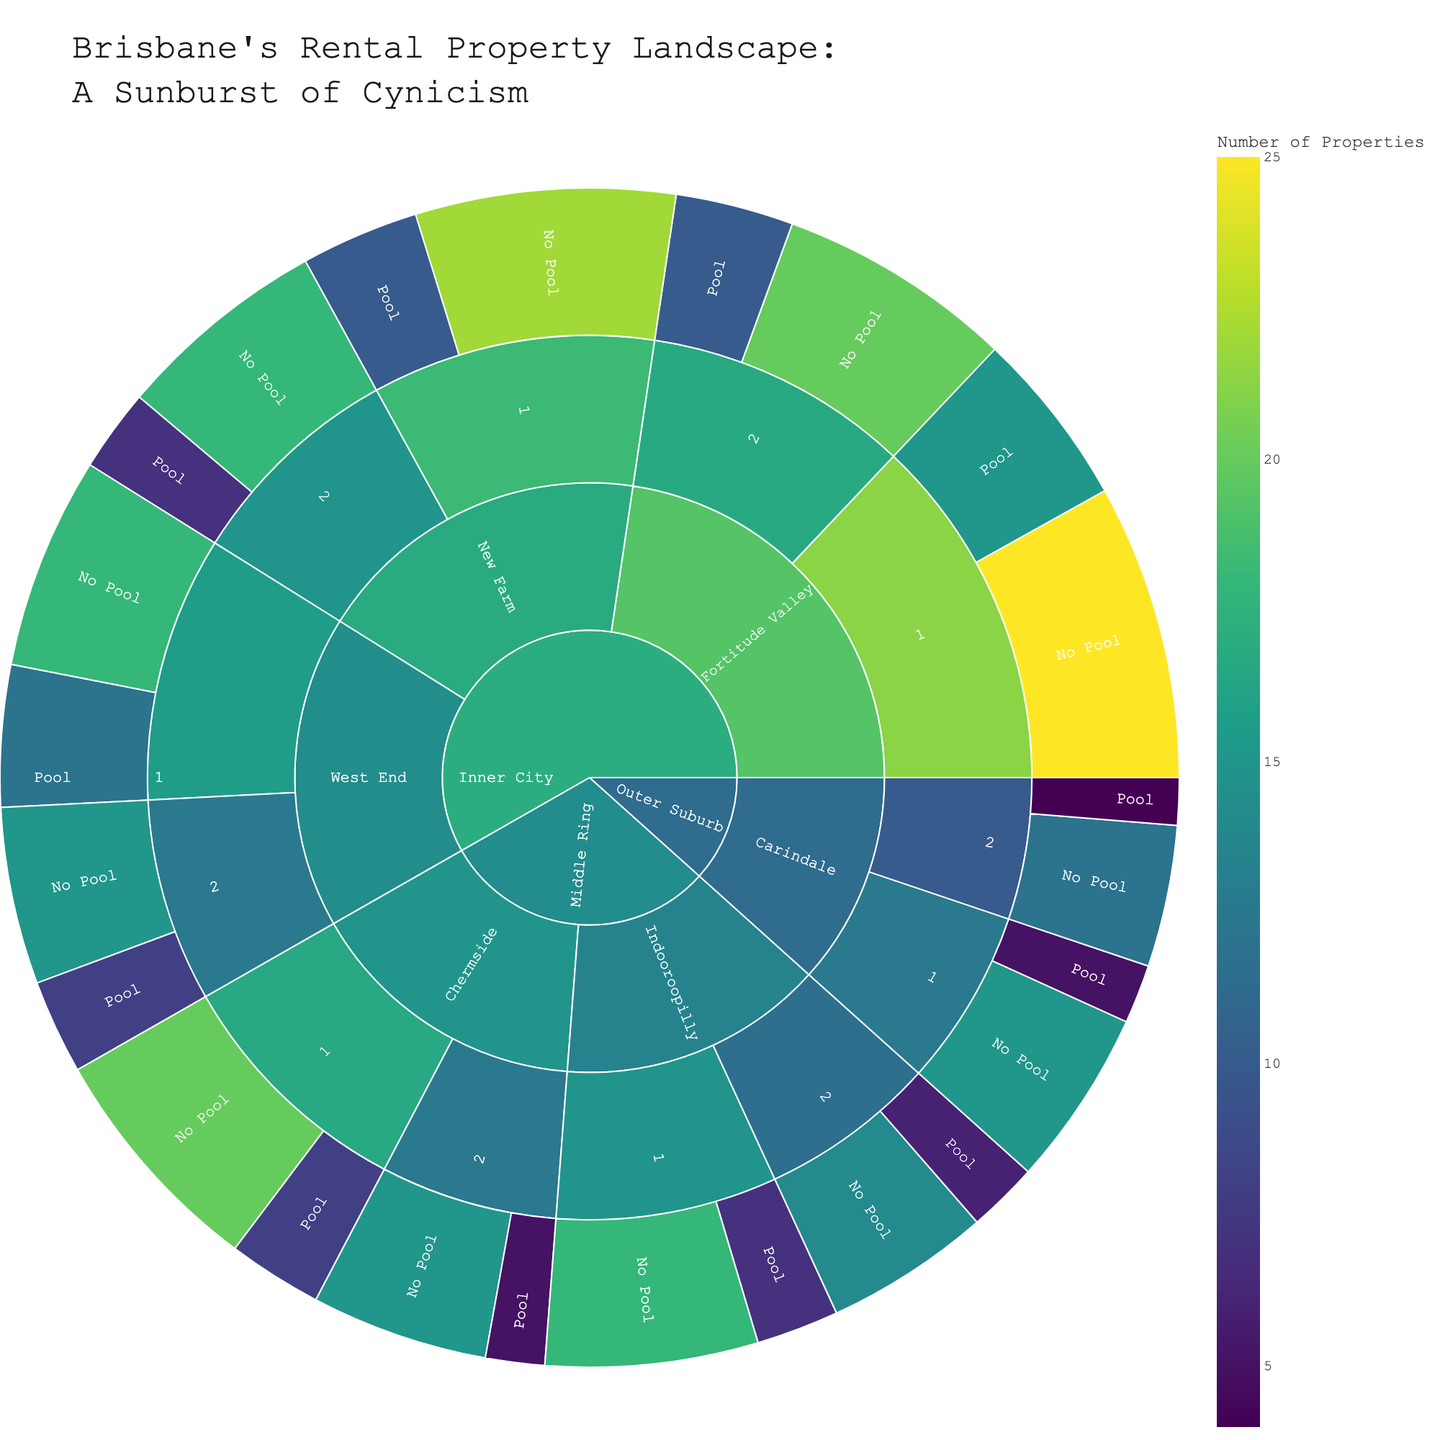What's the title of the sunburst plot? The title is usually at the top of the plot, clearly displayed. To find it, simply read the text at the top.
Answer: Brisbane's Rental Property Landscape: A Sunburst of Cynicism Which suburb in the Inner City has the highest number of 1-bedroom properties with a pool? Look for the "Inner City" segment, then move to the "1-bedroom" sub-segment under each suburb label, and then to the "Pool" sub-segment. Check the values for each suburb.
Answer: Fortitude Valley Compare the total number of rental properties in Fortitude Valley to West End. Which one has more? Sum the values of all sub-groups under Fortitude Valley and do the same for West End. Compare the two sums.
Answer: Fortitude Valley How many more 2-bedroom properties without a pool are available in Chermside compared to Indooroopilly? Locate the "Middle Ring" segment, then find the "Chermside" and "Indooroopilly" sub-segments. Within each, navigate to the "2-bedroom" and "No Pool" sub-segments and note the values. Subtract Indooroopilly's value from Chermside's.
Answer: 1 Which outer suburb has the fewest 1-bedroom properties with a pool? Look for the "Outer Suburb" segment, then move to the "1-bedroom" sub-segment under each suburb label, and then to the "Pool" sub-segment. Identify the subgroup with the lowest value.
Answer: Carindale What is the total number of properties with a pool in the Middle Ring? Add the values of all "Pool" sub-segments within the "Middle Ring" segment.
Answer: 26 Is there a higher number of 2-bedroom properties with a pool or without a pool in New Farm? Within the "New Farm" segment, find the "2-bedroom" sub-segment. Compare the "Pool" and "No Pool" values.
Answer: Without a Pool How does the number of 1-bedroom properties with a pool in Fortitude Valley compare to the entire Inner City with no pool? Find the number under “Fortitude Valley” -> “1-bedroom” -> “Pool,” and sum up all "No Pool" properties under the “Inner City” segment. Compare the two values.
Answer: Inner City with no pool has more What’s the average number of 1-bedroom properties without a pool across all suburbs? Sum the values of all "1-bedroom" and "No Pool" sub-segments, then divide by the number of these sub-segments.
Answer: 19.67 Identify the suburb and property type with the highest number of listings available. Scan through all segments and sub-segments to find the highest value and note its corresponding suburb and property type.
Answer: Fortitude Valley, 1-bedroom, No Pool 